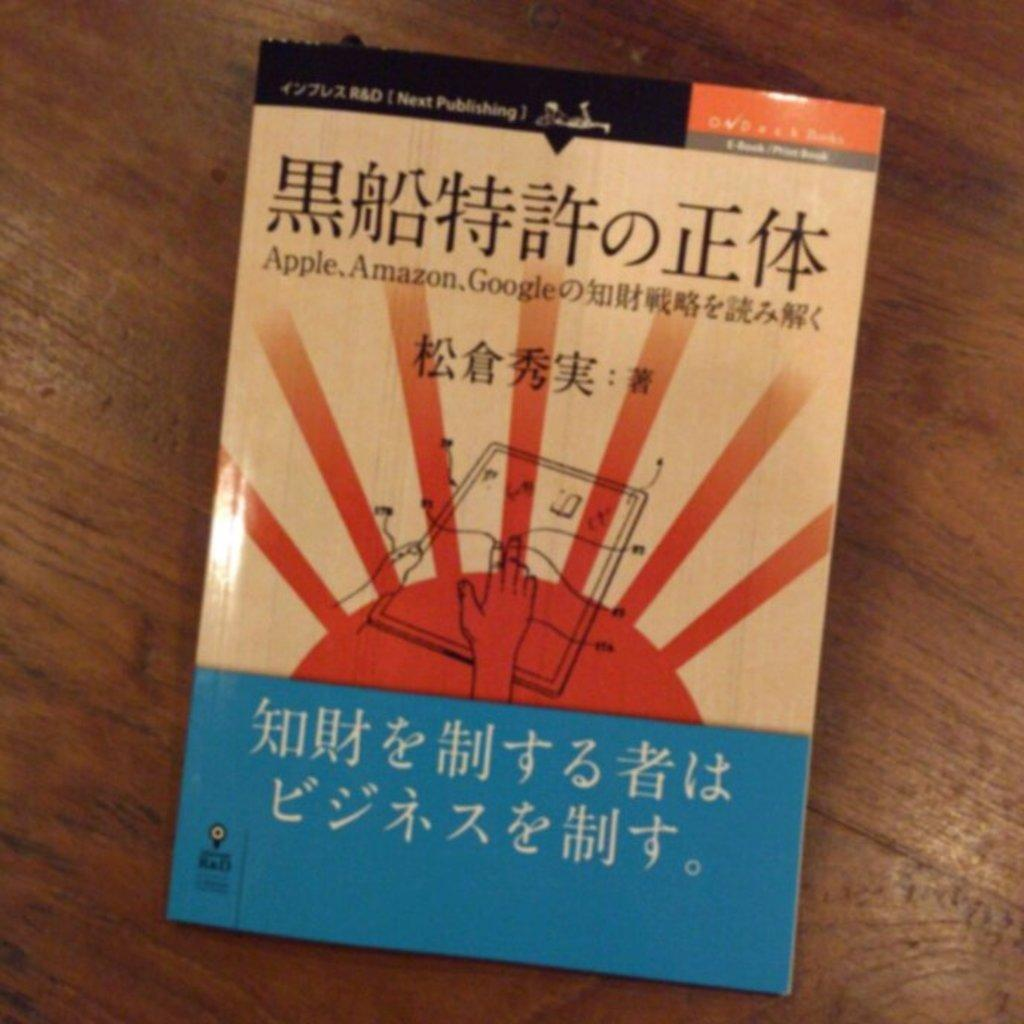<image>
Give a short and clear explanation of the subsequent image. A book in a foreign language with the words Apple, Amazon, Google on it 